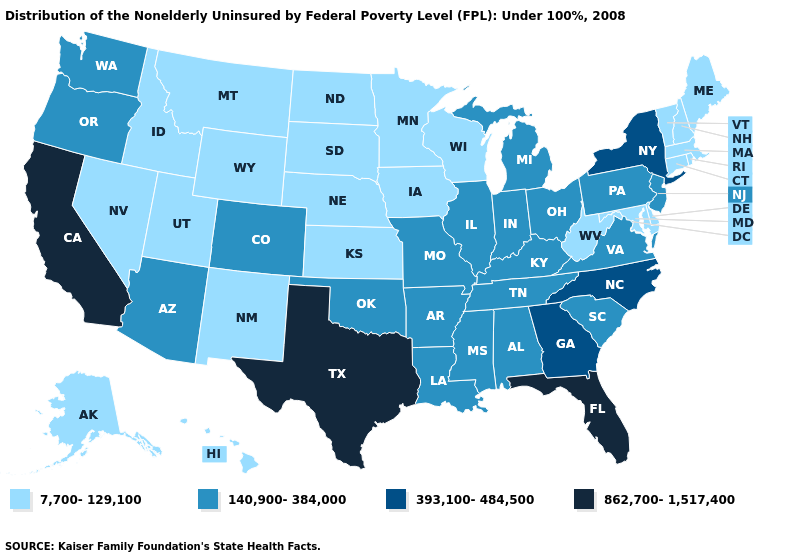What is the value of Massachusetts?
Quick response, please. 7,700-129,100. What is the lowest value in the West?
Write a very short answer. 7,700-129,100. Name the states that have a value in the range 140,900-384,000?
Keep it brief. Alabama, Arizona, Arkansas, Colorado, Illinois, Indiana, Kentucky, Louisiana, Michigan, Mississippi, Missouri, New Jersey, Ohio, Oklahoma, Oregon, Pennsylvania, South Carolina, Tennessee, Virginia, Washington. Does Virginia have a lower value than Texas?
Answer briefly. Yes. What is the lowest value in states that border Arkansas?
Concise answer only. 140,900-384,000. Among the states that border Vermont , which have the highest value?
Answer briefly. New York. Is the legend a continuous bar?
Concise answer only. No. Name the states that have a value in the range 862,700-1,517,400?
Write a very short answer. California, Florida, Texas. Is the legend a continuous bar?
Answer briefly. No. What is the value of Kentucky?
Quick response, please. 140,900-384,000. What is the lowest value in the USA?
Keep it brief. 7,700-129,100. What is the lowest value in states that border Vermont?
Keep it brief. 7,700-129,100. Name the states that have a value in the range 7,700-129,100?
Give a very brief answer. Alaska, Connecticut, Delaware, Hawaii, Idaho, Iowa, Kansas, Maine, Maryland, Massachusetts, Minnesota, Montana, Nebraska, Nevada, New Hampshire, New Mexico, North Dakota, Rhode Island, South Dakota, Utah, Vermont, West Virginia, Wisconsin, Wyoming. What is the value of New York?
Write a very short answer. 393,100-484,500. Does the map have missing data?
Write a very short answer. No. 